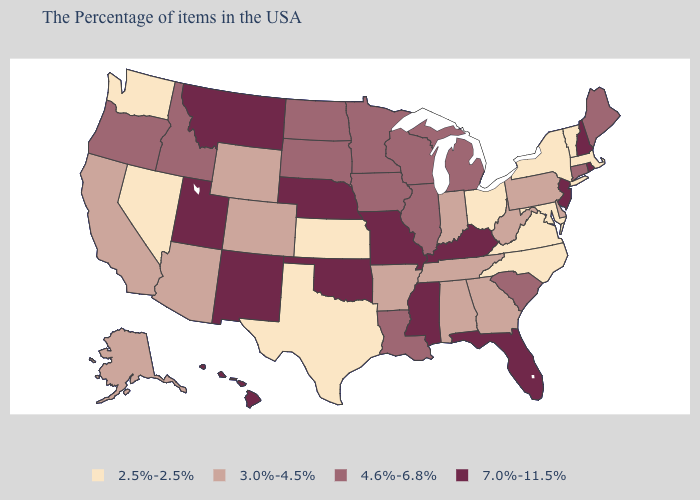Which states have the highest value in the USA?
Be succinct. Rhode Island, New Hampshire, New Jersey, Florida, Kentucky, Mississippi, Missouri, Nebraska, Oklahoma, New Mexico, Utah, Montana, Hawaii. Does Minnesota have the lowest value in the USA?
Quick response, please. No. Name the states that have a value in the range 2.5%-2.5%?
Answer briefly. Massachusetts, Vermont, New York, Maryland, Virginia, North Carolina, Ohio, Kansas, Texas, Nevada, Washington. Name the states that have a value in the range 4.6%-6.8%?
Write a very short answer. Maine, Connecticut, South Carolina, Michigan, Wisconsin, Illinois, Louisiana, Minnesota, Iowa, South Dakota, North Dakota, Idaho, Oregon. Name the states that have a value in the range 2.5%-2.5%?
Concise answer only. Massachusetts, Vermont, New York, Maryland, Virginia, North Carolina, Ohio, Kansas, Texas, Nevada, Washington. Name the states that have a value in the range 7.0%-11.5%?
Keep it brief. Rhode Island, New Hampshire, New Jersey, Florida, Kentucky, Mississippi, Missouri, Nebraska, Oklahoma, New Mexico, Utah, Montana, Hawaii. Does North Dakota have the same value as Kansas?
Concise answer only. No. Among the states that border Pennsylvania , does Ohio have the lowest value?
Quick response, please. Yes. What is the lowest value in states that border Arizona?
Answer briefly. 2.5%-2.5%. What is the value of Arizona?
Be succinct. 3.0%-4.5%. Does Hawaii have a higher value than Washington?
Quick response, please. Yes. Which states hav the highest value in the MidWest?
Concise answer only. Missouri, Nebraska. What is the value of New Hampshire?
Be succinct. 7.0%-11.5%. Which states have the lowest value in the USA?
Short answer required. Massachusetts, Vermont, New York, Maryland, Virginia, North Carolina, Ohio, Kansas, Texas, Nevada, Washington. Is the legend a continuous bar?
Concise answer only. No. 